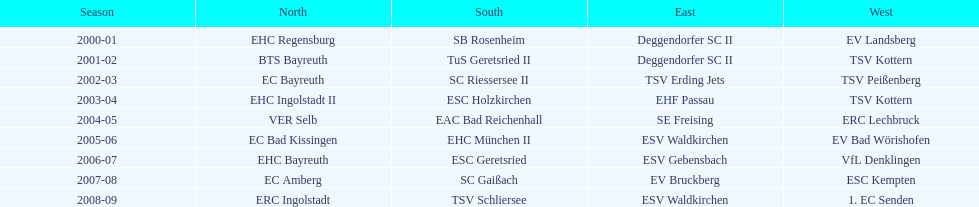Beginning with the 2007-08 season, is ecs kempten present in any of the earlier years? No. Help me parse the entirety of this table. {'header': ['Season', 'North', 'South', 'East', 'West'], 'rows': [['2000-01', 'EHC Regensburg', 'SB Rosenheim', 'Deggendorfer SC II', 'EV Landsberg'], ['2001-02', 'BTS Bayreuth', 'TuS Geretsried II', 'Deggendorfer SC II', 'TSV Kottern'], ['2002-03', 'EC Bayreuth', 'SC Riessersee II', 'TSV Erding Jets', 'TSV Peißenberg'], ['2003-04', 'EHC Ingolstadt II', 'ESC Holzkirchen', 'EHF Passau', 'TSV Kottern'], ['2004-05', 'VER Selb', 'EAC Bad Reichenhall', 'SE Freising', 'ERC Lechbruck'], ['2005-06', 'EC Bad Kissingen', 'EHC München II', 'ESV Waldkirchen', 'EV Bad Wörishofen'], ['2006-07', 'EHC Bayreuth', 'ESC Geretsried', 'ESV Gebensbach', 'VfL Denklingen'], ['2007-08', 'EC Amberg', 'SC Gaißach', 'EV Bruckberg', 'ESC Kempten'], ['2008-09', 'ERC Ingolstadt', 'TSV Schliersee', 'ESV Waldkirchen', '1. EC Senden']]} 